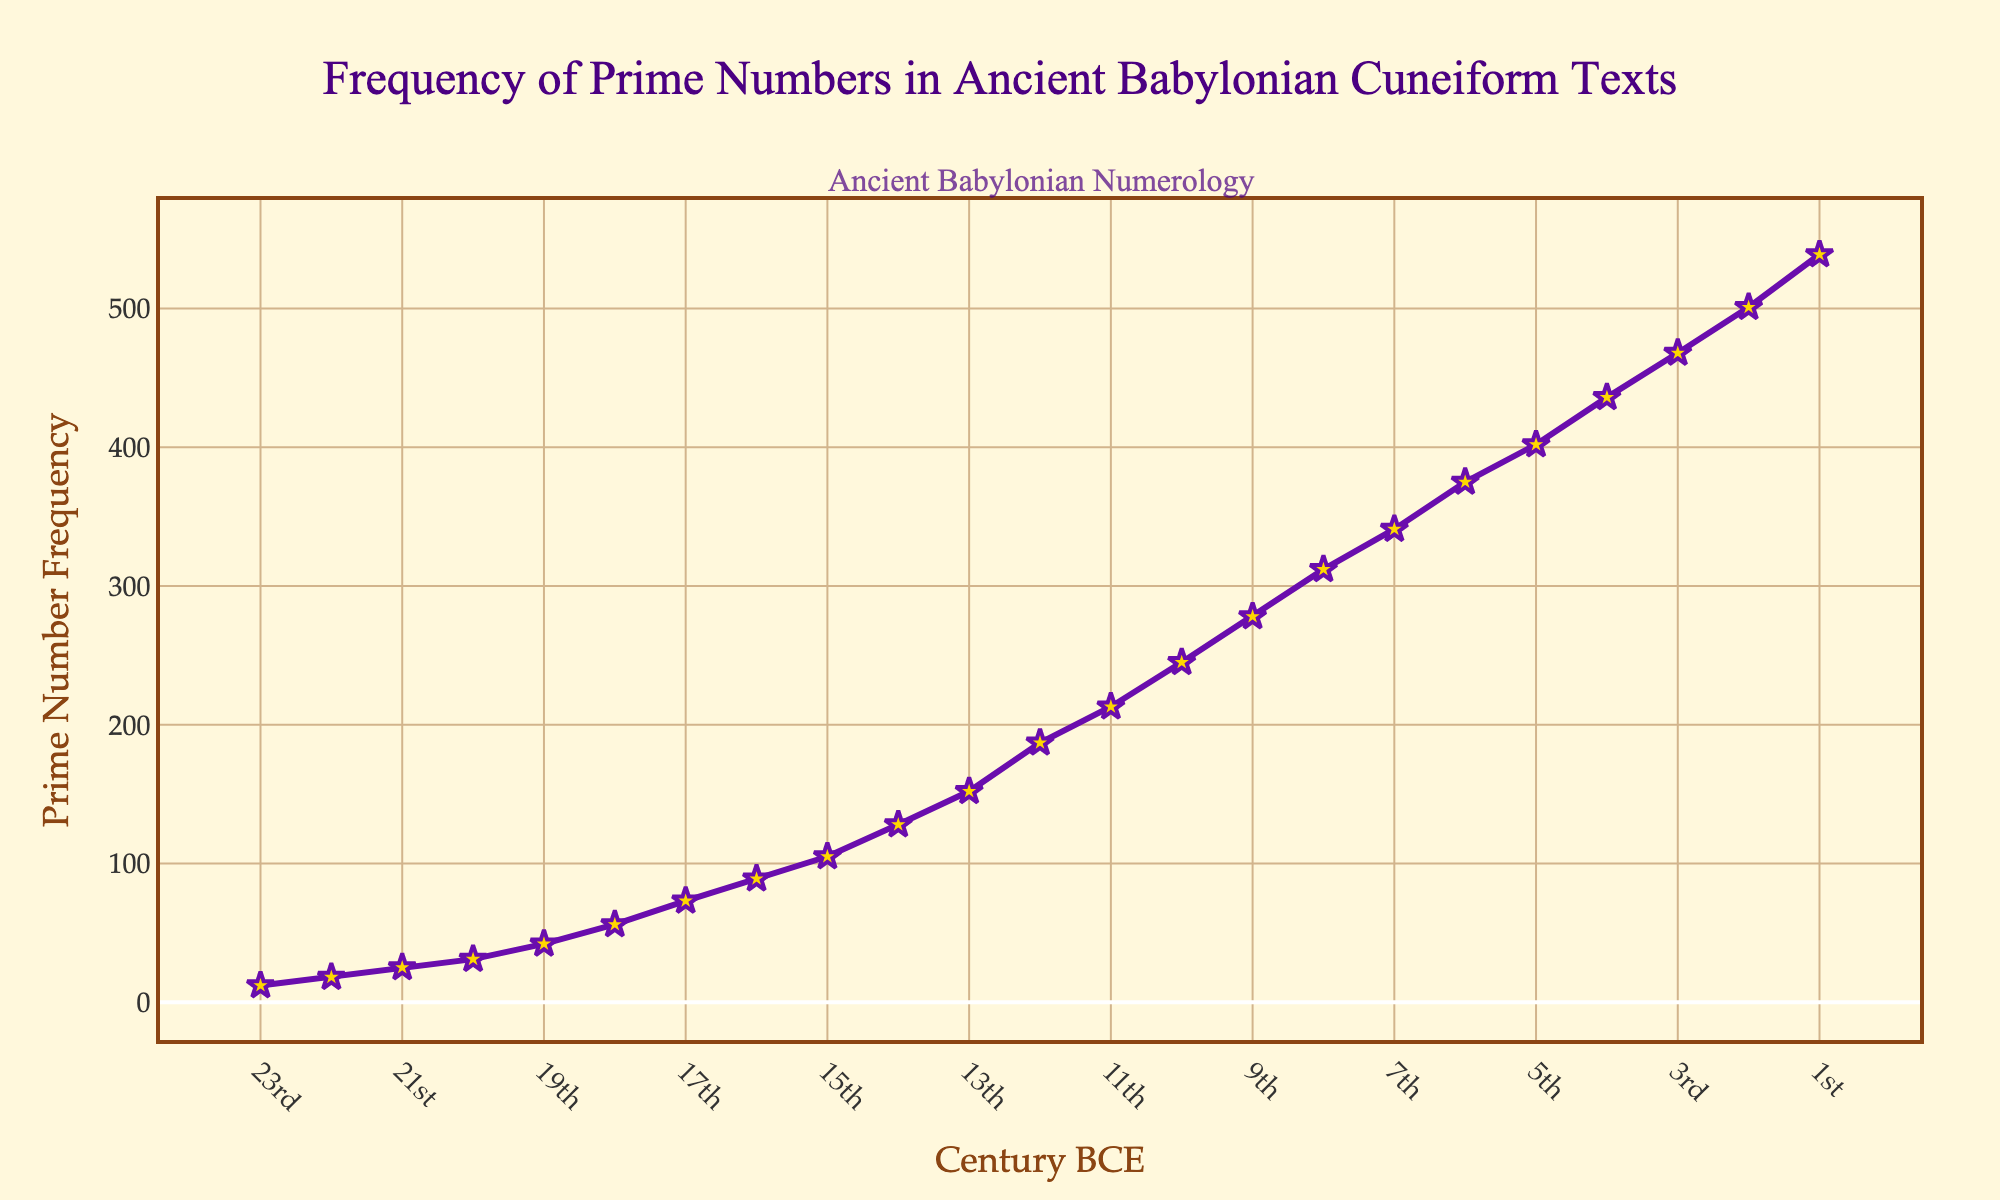When did the highest frequency of prime numbers occur? To find this, we look at the y-axis for the highest value and then trace it back to the corresponding point on the x-axis. The highest frequency of 539 corresponds to the 1st century BCE.
Answer: 1st century BCE How much did the frequency of prime numbers increase from the 23rd to the 1st century BCE? Calculate the difference between the frequency at the 1st century BCE and the 23rd century BCE. The values are 539 and 12, so the increase is 539 - 12 = 527.
Answer: 527 Which centuries show a frequency of over 400? Look for the points above 400 on the y-axis and refer to their x-axis values. These decades are 5th, 4th, 3rd, 2nd, and 1st centuries BCE.
Answer: 5th, 4th, 3rd, 2nd, 1st centuries BCE What is the average frequency between the 20th and 17th centuries BCE? Add the frequencies from these centuries (31, 42, 56, 73) and divide by the number of observations, which is 4. The average is (31 + 42 + 56 + 73) / 4 = 50.5.
Answer: 50.5 Between which centuries BCE did the frequency of prime numbers exceed 100? Identify the first point where y > 100 and the previous century where it was <= 100. This occurs between the 16th and 15th centuries BCE.
Answer: between 16th and 15th centuries BCE Which has a higher frequency: the 10th century BCE or the 3rd century BCE? Compare the values at both centuries: 245 for the 10th and 468 for the 3rd. The 3rd century BCE has a higher frequency.
Answer: 3rd century BCE What is the frequency difference between the 12th and 4th centuries BCE? The frequencies for these centuries are 187 and 436, respectively. The difference is 436 - 187 = 249.
Answer: 249 What visual elements indicate the significance of the trend in the chart? The chart uses a purple line with star markers to highlight the data points, large marker sizes for visibility, bolded century markings on the x-axis, and annotations for the title emphasizing the importance of ancient Babylonian numerology.
Answer: Purple line with star markers, bolded markings, annotations During which centuries BCE does the frequency steadily increase without any dips? Observe the points and look for a continuous upward trend. This occurs from the 18th century BCE to the 1st century BCE.
Answer: 18th century BCE to 1st century BCE 